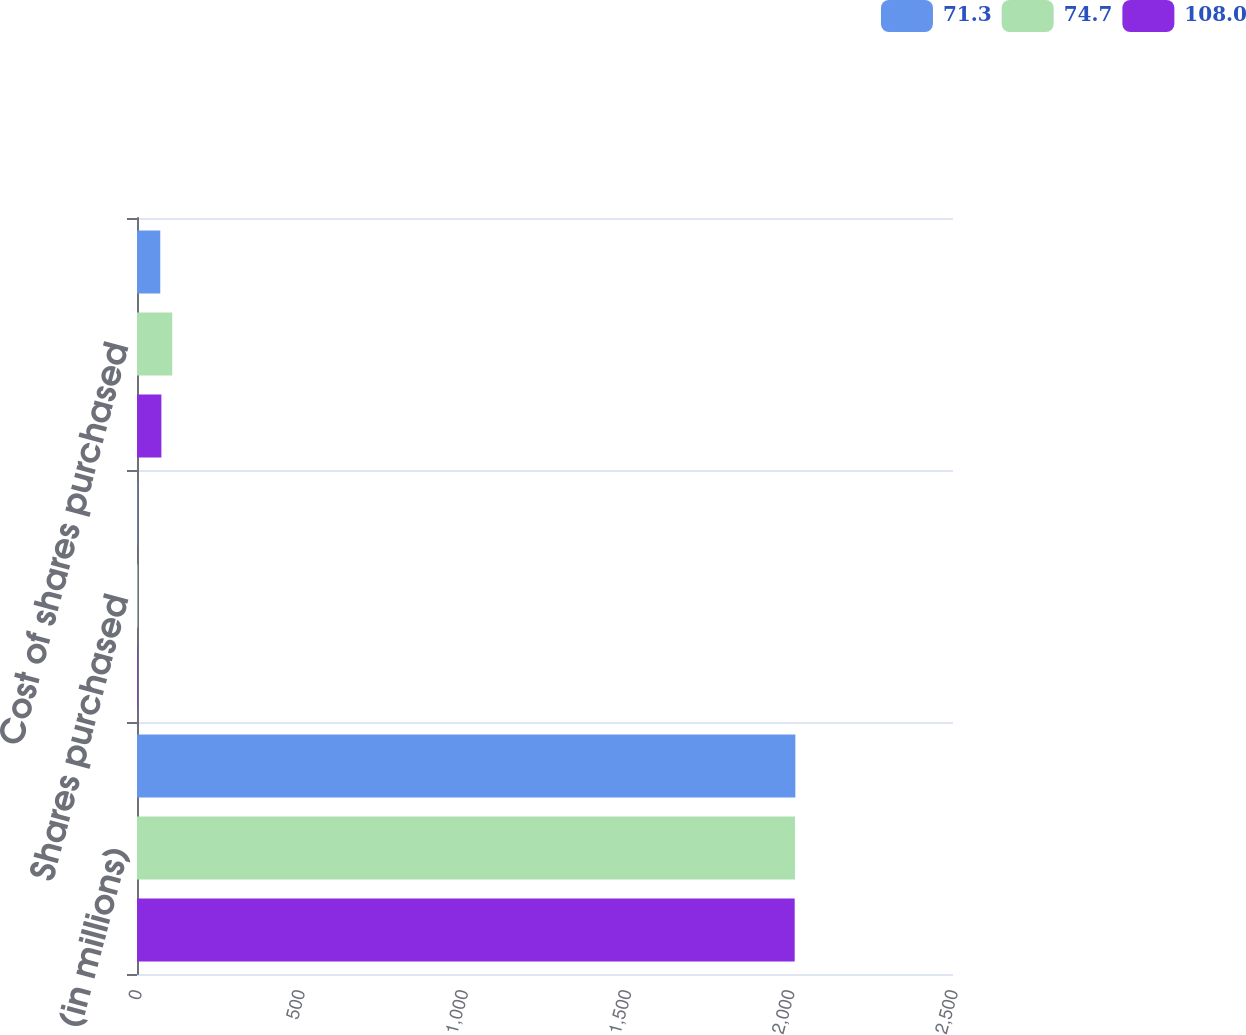<chart> <loc_0><loc_0><loc_500><loc_500><stacked_bar_chart><ecel><fcel>(in millions)<fcel>Shares purchased<fcel>Cost of shares purchased<nl><fcel>71.3<fcel>2017<fcel>1.1<fcel>71.3<nl><fcel>74.7<fcel>2016<fcel>1.8<fcel>108<nl><fcel>108<fcel>2015<fcel>1.5<fcel>74.7<nl></chart> 